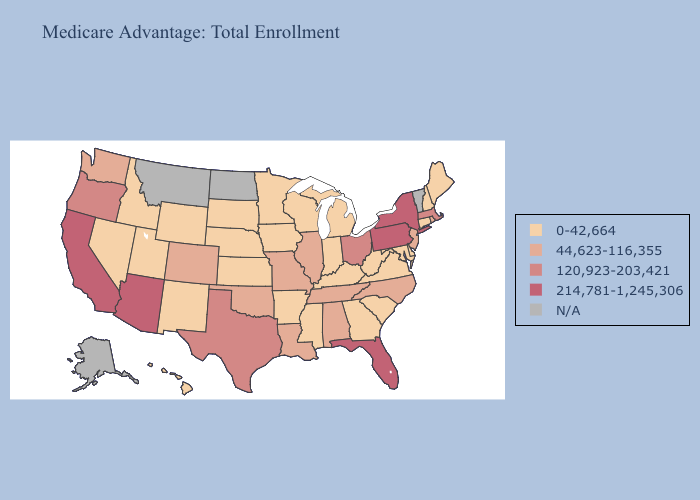Which states have the lowest value in the USA?
Answer briefly. Arkansas, Connecticut, Delaware, Georgia, Hawaii, Iowa, Idaho, Indiana, Kansas, Kentucky, Maryland, Maine, Michigan, Minnesota, Mississippi, Nebraska, New Hampshire, New Mexico, Nevada, South Carolina, South Dakota, Utah, Virginia, Wisconsin, West Virginia, Wyoming. Does the map have missing data?
Be succinct. Yes. Does Maryland have the highest value in the USA?
Short answer required. No. What is the lowest value in the Northeast?
Concise answer only. 0-42,664. Does Wyoming have the highest value in the USA?
Answer briefly. No. Among the states that border Maryland , does Delaware have the lowest value?
Short answer required. Yes. Is the legend a continuous bar?
Quick response, please. No. Name the states that have a value in the range 0-42,664?
Be succinct. Arkansas, Connecticut, Delaware, Georgia, Hawaii, Iowa, Idaho, Indiana, Kansas, Kentucky, Maryland, Maine, Michigan, Minnesota, Mississippi, Nebraska, New Hampshire, New Mexico, Nevada, South Carolina, South Dakota, Utah, Virginia, Wisconsin, West Virginia, Wyoming. What is the value of New Jersey?
Keep it brief. 44,623-116,355. Name the states that have a value in the range N/A?
Write a very short answer. Alaska, Montana, North Dakota, Vermont. What is the value of Illinois?
Write a very short answer. 44,623-116,355. Which states hav the highest value in the West?
Give a very brief answer. Arizona, California. Name the states that have a value in the range 214,781-1,245,306?
Short answer required. Arizona, California, Florida, New York, Pennsylvania. Among the states that border Texas , which have the lowest value?
Give a very brief answer. Arkansas, New Mexico. Is the legend a continuous bar?
Keep it brief. No. 